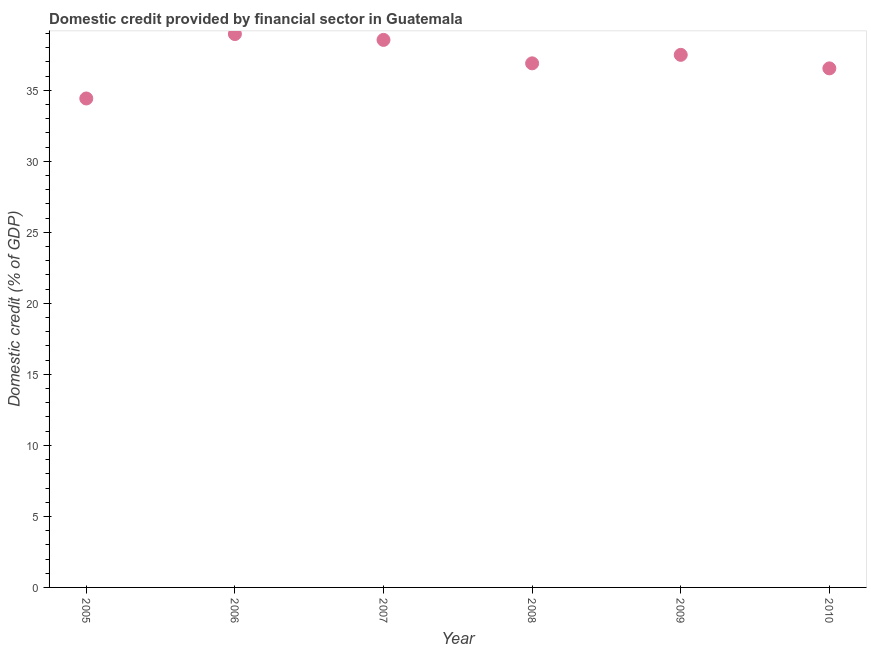What is the domestic credit provided by financial sector in 2009?
Offer a very short reply. 37.5. Across all years, what is the maximum domestic credit provided by financial sector?
Make the answer very short. 38.96. Across all years, what is the minimum domestic credit provided by financial sector?
Provide a short and direct response. 34.43. In which year was the domestic credit provided by financial sector maximum?
Offer a very short reply. 2006. What is the sum of the domestic credit provided by financial sector?
Your response must be concise. 222.89. What is the difference between the domestic credit provided by financial sector in 2008 and 2009?
Provide a short and direct response. -0.6. What is the average domestic credit provided by financial sector per year?
Your answer should be compact. 37.15. What is the median domestic credit provided by financial sector?
Keep it short and to the point. 37.2. What is the ratio of the domestic credit provided by financial sector in 2006 to that in 2007?
Your answer should be compact. 1.01. What is the difference between the highest and the second highest domestic credit provided by financial sector?
Keep it short and to the point. 0.41. What is the difference between the highest and the lowest domestic credit provided by financial sector?
Offer a terse response. 4.54. How many years are there in the graph?
Provide a succinct answer. 6. What is the difference between two consecutive major ticks on the Y-axis?
Ensure brevity in your answer.  5. Does the graph contain any zero values?
Provide a short and direct response. No. Does the graph contain grids?
Offer a very short reply. No. What is the title of the graph?
Make the answer very short. Domestic credit provided by financial sector in Guatemala. What is the label or title of the X-axis?
Provide a short and direct response. Year. What is the label or title of the Y-axis?
Your answer should be very brief. Domestic credit (% of GDP). What is the Domestic credit (% of GDP) in 2005?
Provide a succinct answer. 34.43. What is the Domestic credit (% of GDP) in 2006?
Your answer should be compact. 38.96. What is the Domestic credit (% of GDP) in 2007?
Provide a short and direct response. 38.55. What is the Domestic credit (% of GDP) in 2008?
Keep it short and to the point. 36.9. What is the Domestic credit (% of GDP) in 2009?
Provide a short and direct response. 37.5. What is the Domestic credit (% of GDP) in 2010?
Ensure brevity in your answer.  36.55. What is the difference between the Domestic credit (% of GDP) in 2005 and 2006?
Offer a terse response. -4.54. What is the difference between the Domestic credit (% of GDP) in 2005 and 2007?
Your answer should be compact. -4.13. What is the difference between the Domestic credit (% of GDP) in 2005 and 2008?
Your answer should be very brief. -2.47. What is the difference between the Domestic credit (% of GDP) in 2005 and 2009?
Your answer should be very brief. -3.07. What is the difference between the Domestic credit (% of GDP) in 2005 and 2010?
Ensure brevity in your answer.  -2.12. What is the difference between the Domestic credit (% of GDP) in 2006 and 2007?
Offer a terse response. 0.41. What is the difference between the Domestic credit (% of GDP) in 2006 and 2008?
Keep it short and to the point. 2.06. What is the difference between the Domestic credit (% of GDP) in 2006 and 2009?
Make the answer very short. 1.46. What is the difference between the Domestic credit (% of GDP) in 2006 and 2010?
Offer a very short reply. 2.42. What is the difference between the Domestic credit (% of GDP) in 2007 and 2008?
Provide a succinct answer. 1.65. What is the difference between the Domestic credit (% of GDP) in 2007 and 2009?
Ensure brevity in your answer.  1.05. What is the difference between the Domestic credit (% of GDP) in 2007 and 2010?
Your answer should be very brief. 2.01. What is the difference between the Domestic credit (% of GDP) in 2008 and 2009?
Ensure brevity in your answer.  -0.6. What is the difference between the Domestic credit (% of GDP) in 2008 and 2010?
Keep it short and to the point. 0.35. What is the difference between the Domestic credit (% of GDP) in 2009 and 2010?
Offer a terse response. 0.95. What is the ratio of the Domestic credit (% of GDP) in 2005 to that in 2006?
Make the answer very short. 0.88. What is the ratio of the Domestic credit (% of GDP) in 2005 to that in 2007?
Offer a terse response. 0.89. What is the ratio of the Domestic credit (% of GDP) in 2005 to that in 2008?
Your answer should be compact. 0.93. What is the ratio of the Domestic credit (% of GDP) in 2005 to that in 2009?
Make the answer very short. 0.92. What is the ratio of the Domestic credit (% of GDP) in 2005 to that in 2010?
Provide a short and direct response. 0.94. What is the ratio of the Domestic credit (% of GDP) in 2006 to that in 2008?
Make the answer very short. 1.06. What is the ratio of the Domestic credit (% of GDP) in 2006 to that in 2009?
Ensure brevity in your answer.  1.04. What is the ratio of the Domestic credit (% of GDP) in 2006 to that in 2010?
Your answer should be very brief. 1.07. What is the ratio of the Domestic credit (% of GDP) in 2007 to that in 2008?
Provide a short and direct response. 1.04. What is the ratio of the Domestic credit (% of GDP) in 2007 to that in 2009?
Provide a succinct answer. 1.03. What is the ratio of the Domestic credit (% of GDP) in 2007 to that in 2010?
Your answer should be compact. 1.05. What is the ratio of the Domestic credit (% of GDP) in 2008 to that in 2009?
Offer a terse response. 0.98. What is the ratio of the Domestic credit (% of GDP) in 2008 to that in 2010?
Provide a succinct answer. 1.01. What is the ratio of the Domestic credit (% of GDP) in 2009 to that in 2010?
Your answer should be very brief. 1.03. 